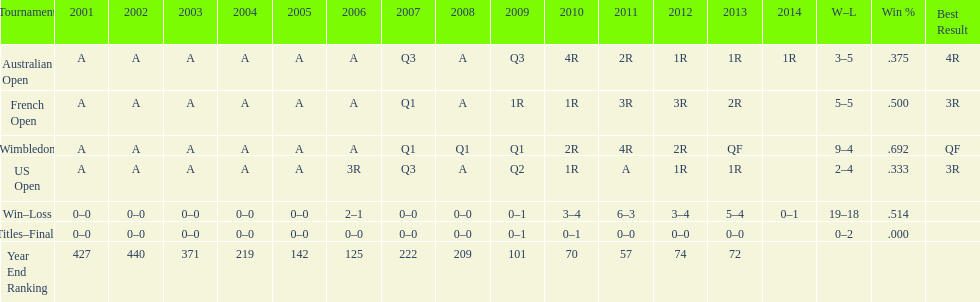In which years were there only 1 loss? 2006, 2009, 2014. 